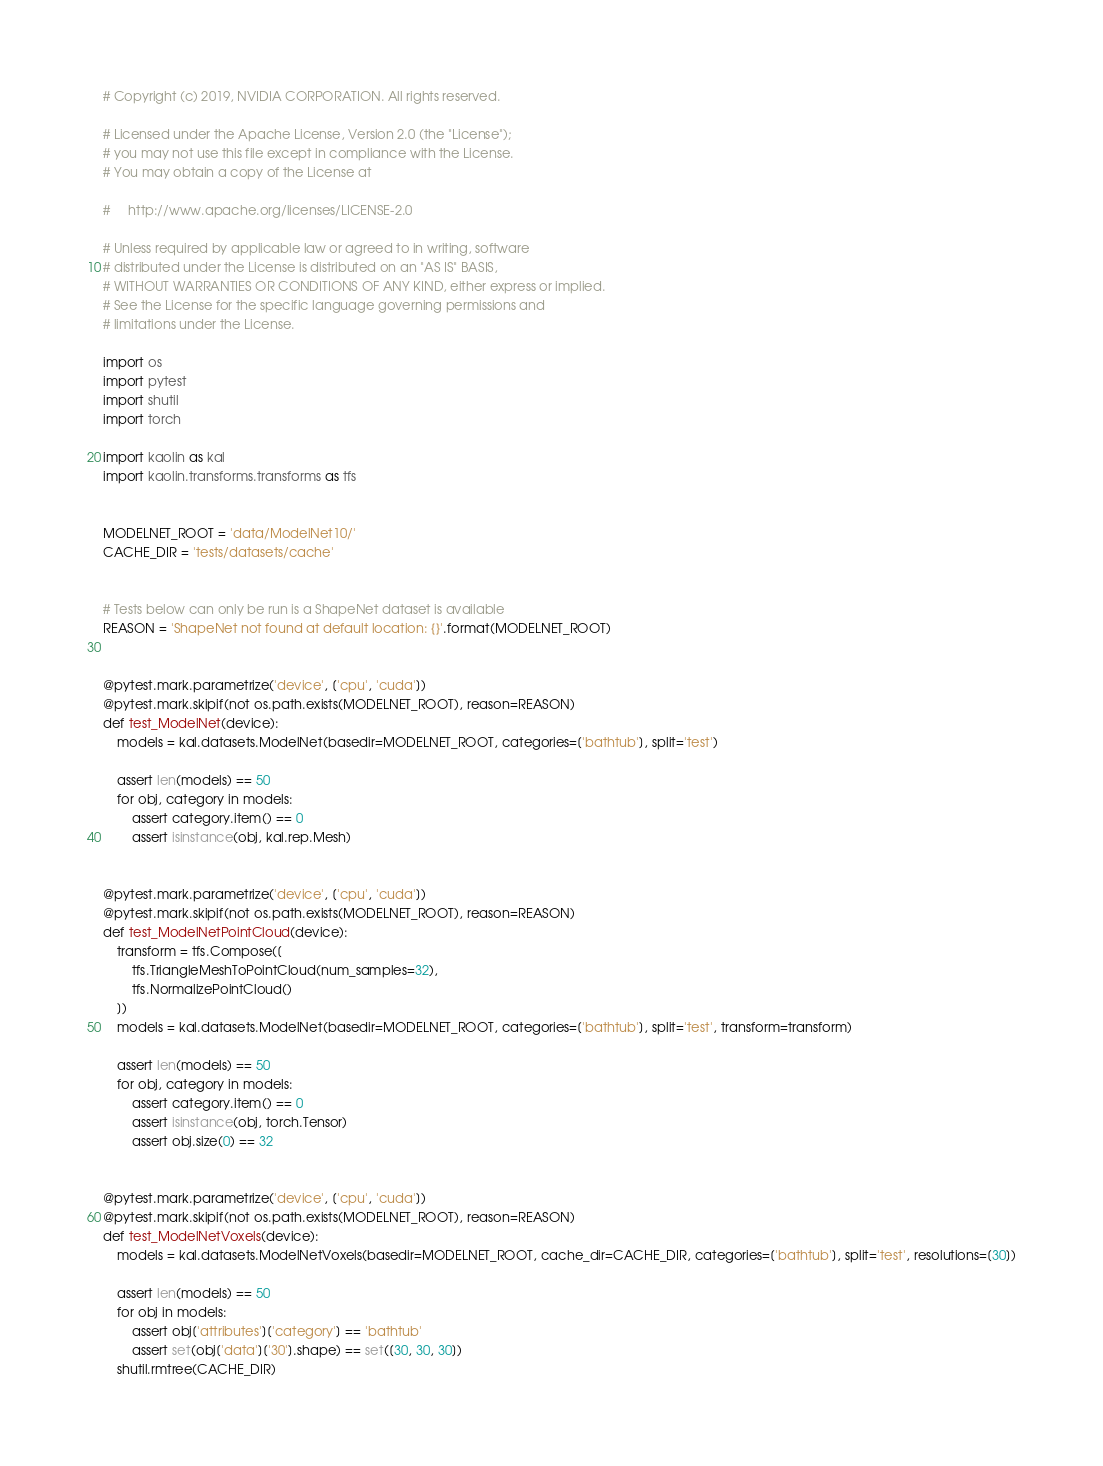<code> <loc_0><loc_0><loc_500><loc_500><_Python_># Copyright (c) 2019, NVIDIA CORPORATION. All rights reserved.

# Licensed under the Apache License, Version 2.0 (the "License");
# you may not use this file except in compliance with the License.
# You may obtain a copy of the License at

#     http://www.apache.org/licenses/LICENSE-2.0

# Unless required by applicable law or agreed to in writing, software
# distributed under the License is distributed on an "AS IS" BASIS,
# WITHOUT WARRANTIES OR CONDITIONS OF ANY KIND, either express or implied.
# See the License for the specific language governing permissions and
# limitations under the License.

import os
import pytest
import shutil
import torch

import kaolin as kal
import kaolin.transforms.transforms as tfs


MODELNET_ROOT = 'data/ModelNet10/'
CACHE_DIR = 'tests/datasets/cache'


# Tests below can only be run is a ShapeNet dataset is available
REASON = 'ShapeNet not found at default location: {}'.format(MODELNET_ROOT)


@pytest.mark.parametrize('device', ['cpu', 'cuda'])
@pytest.mark.skipif(not os.path.exists(MODELNET_ROOT), reason=REASON)
def test_ModelNet(device): 
    models = kal.datasets.ModelNet(basedir=MODELNET_ROOT, categories=['bathtub'], split='test')

    assert len(models) == 50
    for obj, category in models: 
        assert category.item() == 0
        assert isinstance(obj, kal.rep.Mesh)


@pytest.mark.parametrize('device', ['cpu', 'cuda'])
@pytest.mark.skipif(not os.path.exists(MODELNET_ROOT), reason=REASON)
def test_ModelNetPointCloud(device): 
    transform = tfs.Compose([
        tfs.TriangleMeshToPointCloud(num_samples=32),
        tfs.NormalizePointCloud()
    ])
    models = kal.datasets.ModelNet(basedir=MODELNET_ROOT, categories=['bathtub'], split='test', transform=transform)

    assert len(models) == 50
    for obj, category in models: 
        assert category.item() == 0
        assert isinstance(obj, torch.Tensor)
        assert obj.size(0) == 32


@pytest.mark.parametrize('device', ['cpu', 'cuda'])
@pytest.mark.skipif(not os.path.exists(MODELNET_ROOT), reason=REASON)
def test_ModelNetVoxels(device): 
    models = kal.datasets.ModelNetVoxels(basedir=MODELNET_ROOT, cache_dir=CACHE_DIR, categories=['bathtub'], split='test', resolutions=[30])

    assert len(models) == 50
    for obj in models: 
        assert obj['attributes']['category'] == 'bathtub'
        assert set(obj['data']['30'].shape) == set([30, 30, 30]) 
    shutil.rmtree(CACHE_DIR)
</code> 